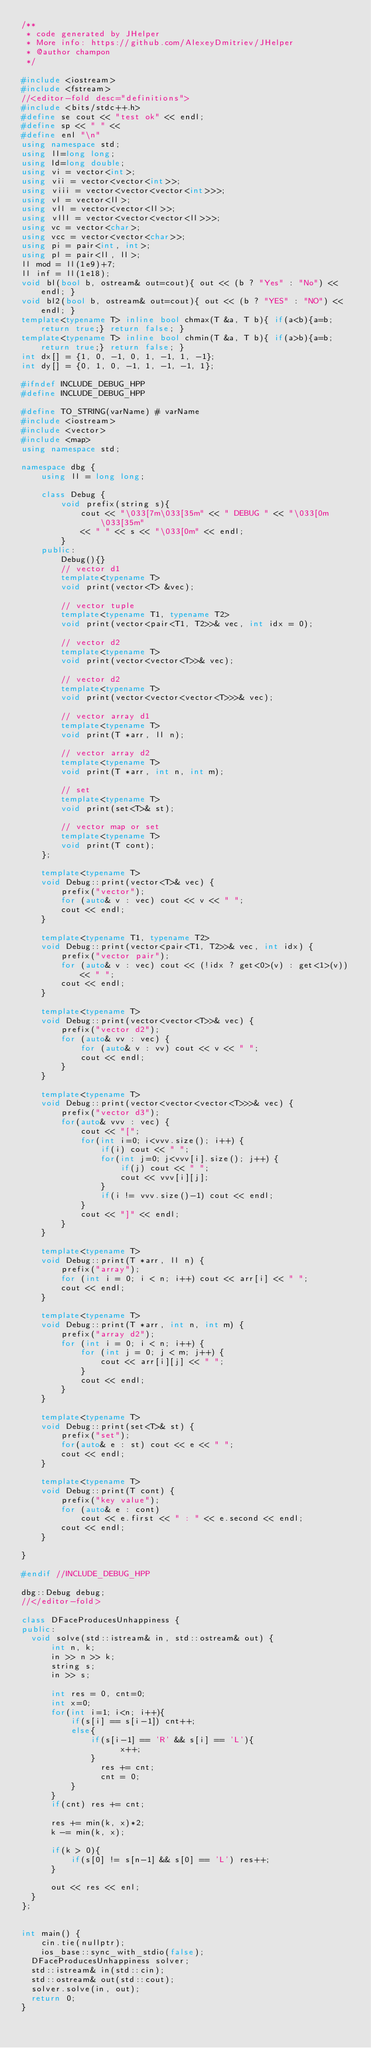Convert code to text. <code><loc_0><loc_0><loc_500><loc_500><_C++_>/**
 * code generated by JHelper
 * More info: https://github.com/AlexeyDmitriev/JHelper
 * @author champon
 */

#include <iostream>
#include <fstream>
//<editor-fold desc="definitions">
#include <bits/stdc++.h>
#define se cout << "test ok" << endl;
#define sp << " " <<
#define enl "\n"
using namespace std;
using ll=long long;
using ld=long double;
using vi = vector<int>;
using vii = vector<vector<int>>;
using viii = vector<vector<vector<int>>>;
using vl = vector<ll>;
using vll = vector<vector<ll>>;
using vlll = vector<vector<vector<ll>>>;
using vc = vector<char>;
using vcc = vector<vector<char>>;
using pi = pair<int, int>;
using pl = pair<ll, ll>;
ll mod = ll(1e9)+7;
ll inf = ll(1e18);
void bl(bool b, ostream& out=cout){ out << (b ? "Yes" : "No") << endl; }
void bl2(bool b, ostream& out=cout){ out << (b ? "YES" : "NO") << endl; }
template<typename T> inline bool chmax(T &a, T b){ if(a<b){a=b; return true;} return false; }
template<typename T> inline bool chmin(T &a, T b){ if(a>b){a=b; return true;} return false; }
int dx[] = {1, 0, -1, 0, 1, -1, 1, -1};
int dy[] = {0, 1, 0, -1, 1, -1, -1, 1};

#ifndef INCLUDE_DEBUG_HPP
#define INCLUDE_DEBUG_HPP

#define TO_STRING(varName) # varName
#include <iostream>
#include <vector>
#include <map>
using namespace std;

namespace dbg {
    using ll = long long;

    class Debug {
        void prefix(string s){
            cout << "\033[7m\033[35m" << " DEBUG " << "\033[0m\033[35m"
            << " " << s << "\033[0m" << endl;
        }
    public:
        Debug(){}
        // vector d1
        template<typename T>
        void print(vector<T> &vec);

        // vector tuple
        template<typename T1, typename T2>
        void print(vector<pair<T1, T2>>& vec, int idx = 0);

        // vector d2
        template<typename T>
        void print(vector<vector<T>>& vec);

        // vector d2
        template<typename T>
        void print(vector<vector<vector<T>>>& vec);

        // vector array d1
        template<typename T>
        void print(T *arr, ll n);

        // vector array d2
        template<typename T>
        void print(T *arr, int n, int m);

        // set
        template<typename T>
        void print(set<T>& st);

        // vector map or set
        template<typename T>
        void print(T cont);
    };

    template<typename T>
    void Debug::print(vector<T>& vec) {
        prefix("vector");
        for (auto& v : vec) cout << v << " ";
        cout << endl;
    }

    template<typename T1, typename T2>
    void Debug::print(vector<pair<T1, T2>>& vec, int idx) {
        prefix("vector pair");
        for (auto& v : vec) cout << (!idx ? get<0>(v) : get<1>(v)) << " ";
        cout << endl;
    }

    template<typename T>
    void Debug::print(vector<vector<T>>& vec) {
        prefix("vector d2");
        for (auto& vv : vec) {
            for (auto& v : vv) cout << v << " ";
            cout << endl;
        }
    }

    template<typename T>
    void Debug::print(vector<vector<vector<T>>>& vec) {
        prefix("vector d3");
        for(auto& vvv : vec) {
            cout << "[";
            for(int i=0; i<vvv.size(); i++) {
                if(i) cout << " ";
                for(int j=0; j<vvv[i].size(); j++) {
                    if(j) cout << " ";
                    cout << vvv[i][j];
                }
                if(i != vvv.size()-1) cout << endl;
            }
            cout << "]" << endl;
        }
    }

    template<typename T>
    void Debug::print(T *arr, ll n) {
        prefix("array");
        for (int i = 0; i < n; i++) cout << arr[i] << " ";
        cout << endl;
    }

    template<typename T>
    void Debug::print(T *arr, int n, int m) {
        prefix("array d2");
        for (int i = 0; i < n; i++) {
            for (int j = 0; j < m; j++) {
                cout << arr[i][j] << " ";
            }
            cout << endl;
        }
    }

    template<typename T>
    void Debug::print(set<T>& st) {
        prefix("set");
        for(auto& e : st) cout << e << " ";
        cout << endl;
    }

    template<typename T>
    void Debug::print(T cont) {
        prefix("key value");
        for (auto& e : cont)
            cout << e.first << " : " << e.second << endl;
        cout << endl;
    }

}

#endif //INCLUDE_DEBUG_HPP

dbg::Debug debug;
//</editor-fold>

class DFaceProducesUnhappiness {
public:
	void solve(std::istream& in, std::ostream& out) {
	    int n, k;
	    in >> n >> k;
	    string s;
	    in >> s;

	    int res = 0, cnt=0;
	    int x=0;
	    for(int i=1; i<n; i++){
	        if(s[i] == s[i-1]) cnt++;
	        else{
	            if(s[i-1] == 'R' && s[i] == 'L'){
                    x++;
	            }
                res += cnt;
                cnt = 0;
	        }
	    }
	    if(cnt) res += cnt;

	    res += min(k, x)*2;
	    k -= min(k, x);

	    if(k > 0){
	        if(s[0] != s[n-1] && s[0] == 'L') res++;
	    }

	    out << res << enl;
	}
};


int main() {
    cin.tie(nullptr);
    ios_base::sync_with_stdio(false);
	DFaceProducesUnhappiness solver;
	std::istream& in(std::cin);
	std::ostream& out(std::cout);
	solver.solve(in, out);
	return 0;
}
</code> 